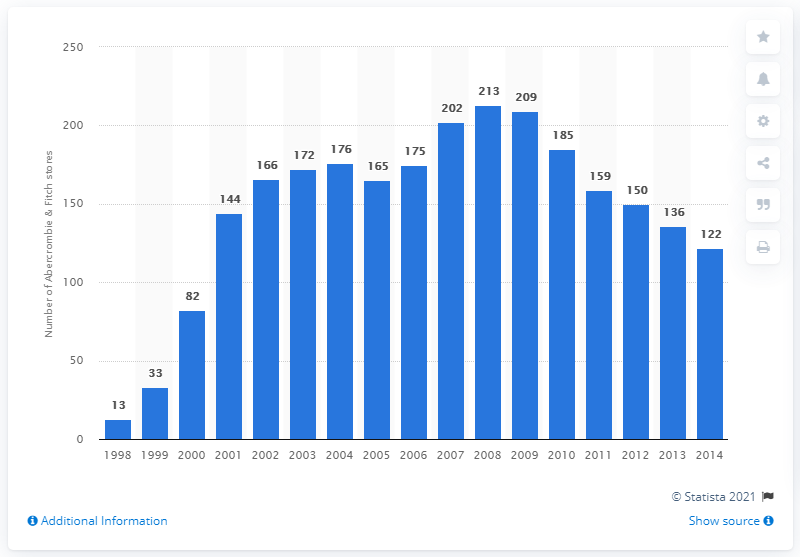Identify some key points in this picture. In 2010, the global number of Abercrombie Kids stores was 185. 